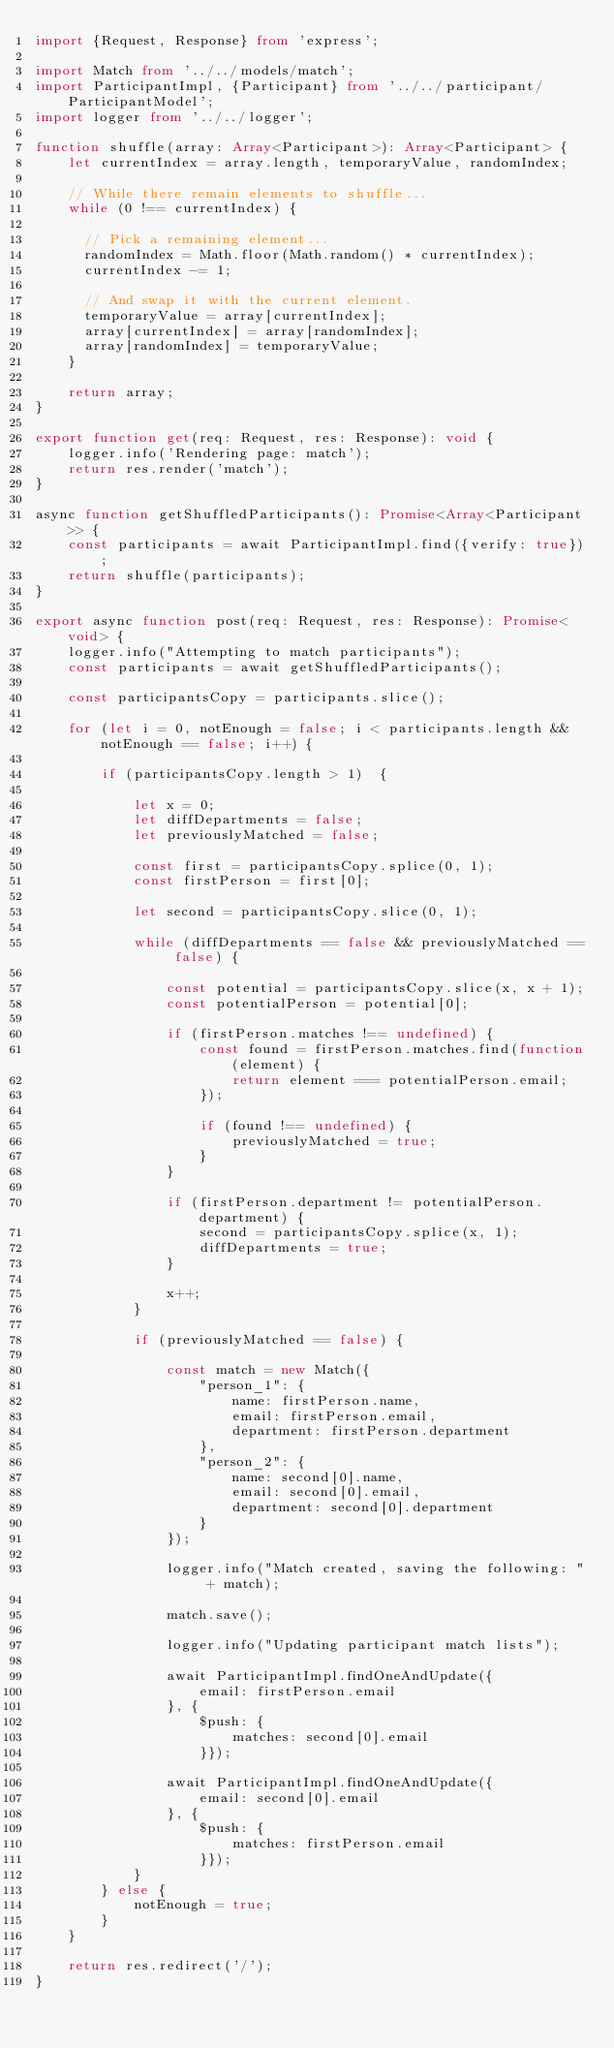Convert code to text. <code><loc_0><loc_0><loc_500><loc_500><_TypeScript_>import {Request, Response} from 'express';

import Match from '../../models/match';
import ParticipantImpl, {Participant} from '../../participant/ParticipantModel';
import logger from '../../logger';

function shuffle(array: Array<Participant>): Array<Participant> {
    let currentIndex = array.length, temporaryValue, randomIndex;
  
    // While there remain elements to shuffle...
    while (0 !== currentIndex) {
  
      // Pick a remaining element...
      randomIndex = Math.floor(Math.random() * currentIndex);
      currentIndex -= 1;
  
      // And swap it with the current element.
      temporaryValue = array[currentIndex];
      array[currentIndex] = array[randomIndex];
      array[randomIndex] = temporaryValue;
    }
  
    return array;
}

export function get(req: Request, res: Response): void {
    logger.info('Rendering page: match');
    return res.render('match');
}

async function getShuffledParticipants(): Promise<Array<Participant>> {
    const participants = await ParticipantImpl.find({verify: true});
    return shuffle(participants);
}

export async function post(req: Request, res: Response): Promise<void> {
    logger.info("Attempting to match participants");
    const participants = await getShuffledParticipants();

    const participantsCopy = participants.slice();
    
    for (let i = 0, notEnough = false; i < participants.length && notEnough == false; i++) {
        
        if (participantsCopy.length > 1)  {

            let x = 0;
            let diffDepartments = false;
            let previouslyMatched = false;

            const first = participantsCopy.splice(0, 1);
            const firstPerson = first[0];

            let second = participantsCopy.slice(0, 1);

            while (diffDepartments == false && previouslyMatched == false) {

                const potential = participantsCopy.slice(x, x + 1);
                const potentialPerson = potential[0];

                if (firstPerson.matches !== undefined) {
                    const found = firstPerson.matches.find(function(element) {
                        return element === potentialPerson.email;
                    });

                    if (found !== undefined) {
                        previouslyMatched = true;
                    }
                }

                if (firstPerson.department != potentialPerson.department) {
                    second = participantsCopy.splice(x, 1);
                    diffDepartments = true;
                }

                x++;
            }

            if (previouslyMatched == false) {

                const match = new Match({
                    "person_1": {
                        name: firstPerson.name,
                        email: firstPerson.email,
                        department: firstPerson.department
                    },
                    "person_2": {
                        name: second[0].name,
                        email: second[0].email,
                        department: second[0].department
                    }
                });

                logger.info("Match created, saving the following: " + match);

                match.save();

                logger.info("Updating participant match lists");

                await ParticipantImpl.findOneAndUpdate({
                    email: firstPerson.email
                }, {
                    $push: {
                        matches: second[0].email
                    }});

                await ParticipantImpl.findOneAndUpdate({
                    email: second[0].email
                }, {
                    $push: {
                        matches: firstPerson.email
                    }});
            }
        } else {
            notEnough = true;
        }
    }

    return res.redirect('/');
}</code> 